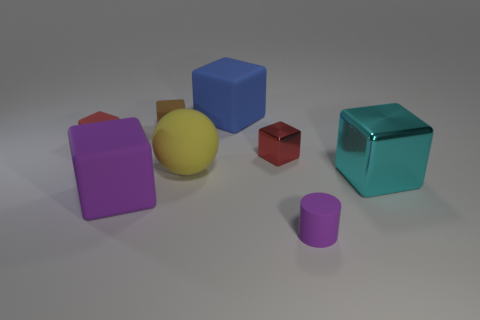What is the color of the large shiny object that is the same shape as the big purple rubber thing?
Ensure brevity in your answer.  Cyan. Is there anything else that is the same shape as the yellow thing?
Your answer should be compact. No. Is the number of large rubber things greater than the number of big rubber blocks?
Make the answer very short. Yes. How many other things are there of the same material as the purple cylinder?
Ensure brevity in your answer.  5. What shape is the thing that is in front of the purple matte object behind the small thing that is in front of the cyan cube?
Provide a short and direct response. Cylinder. Is the number of brown things right of the blue cube less than the number of balls in front of the large metallic object?
Keep it short and to the point. No. Are there any large objects of the same color as the cylinder?
Ensure brevity in your answer.  Yes. Is the material of the brown block the same as the red cube right of the brown block?
Provide a succinct answer. No. There is a small red cube that is to the left of the large yellow matte sphere; are there any big blocks in front of it?
Ensure brevity in your answer.  Yes. There is a large cube that is on the left side of the small rubber cylinder and behind the purple rubber cube; what is its color?
Your answer should be compact. Blue. 